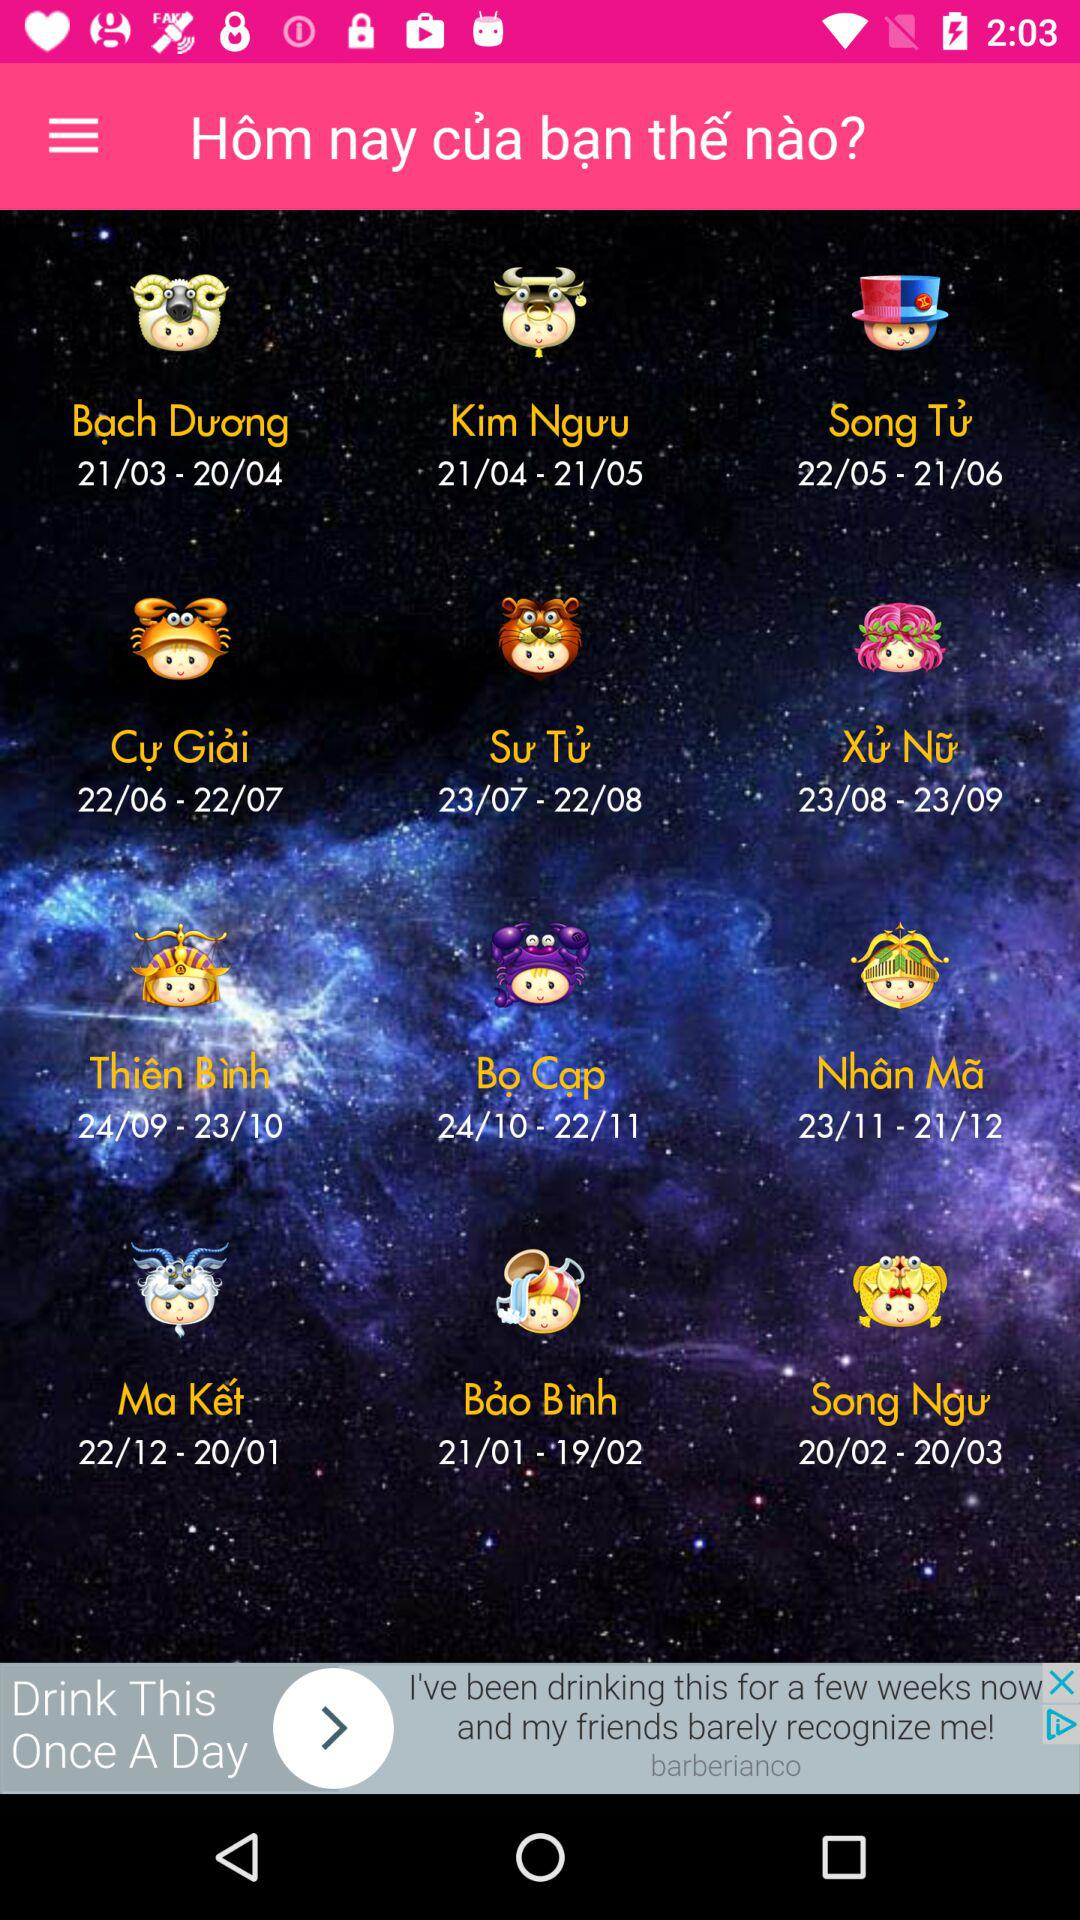How many zodiac signs are there in total?
Answer the question using a single word or phrase. 12 